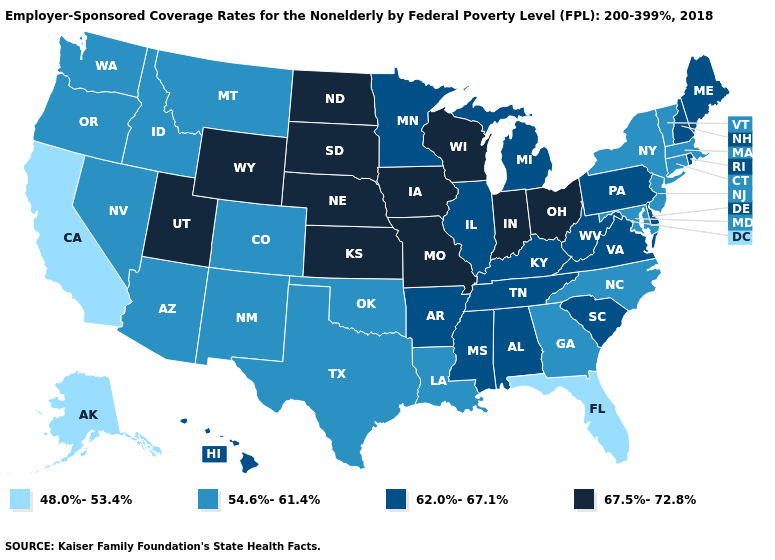Does Idaho have the highest value in the USA?
Short answer required. No. Is the legend a continuous bar?
Answer briefly. No. What is the value of California?
Write a very short answer. 48.0%-53.4%. Name the states that have a value in the range 62.0%-67.1%?
Write a very short answer. Alabama, Arkansas, Delaware, Hawaii, Illinois, Kentucky, Maine, Michigan, Minnesota, Mississippi, New Hampshire, Pennsylvania, Rhode Island, South Carolina, Tennessee, Virginia, West Virginia. Among the states that border Ohio , which have the lowest value?
Concise answer only. Kentucky, Michigan, Pennsylvania, West Virginia. Which states hav the highest value in the Northeast?
Be succinct. Maine, New Hampshire, Pennsylvania, Rhode Island. What is the value of Arkansas?
Write a very short answer. 62.0%-67.1%. What is the highest value in the USA?
Write a very short answer. 67.5%-72.8%. Which states have the lowest value in the USA?
Write a very short answer. Alaska, California, Florida. Among the states that border Ohio , does Indiana have the lowest value?
Short answer required. No. Name the states that have a value in the range 54.6%-61.4%?
Quick response, please. Arizona, Colorado, Connecticut, Georgia, Idaho, Louisiana, Maryland, Massachusetts, Montana, Nevada, New Jersey, New Mexico, New York, North Carolina, Oklahoma, Oregon, Texas, Vermont, Washington. Does New Jersey have a lower value than Utah?
Answer briefly. Yes. Does California have the lowest value in the USA?
Give a very brief answer. Yes. Does Oklahoma have the highest value in the USA?
Write a very short answer. No. 